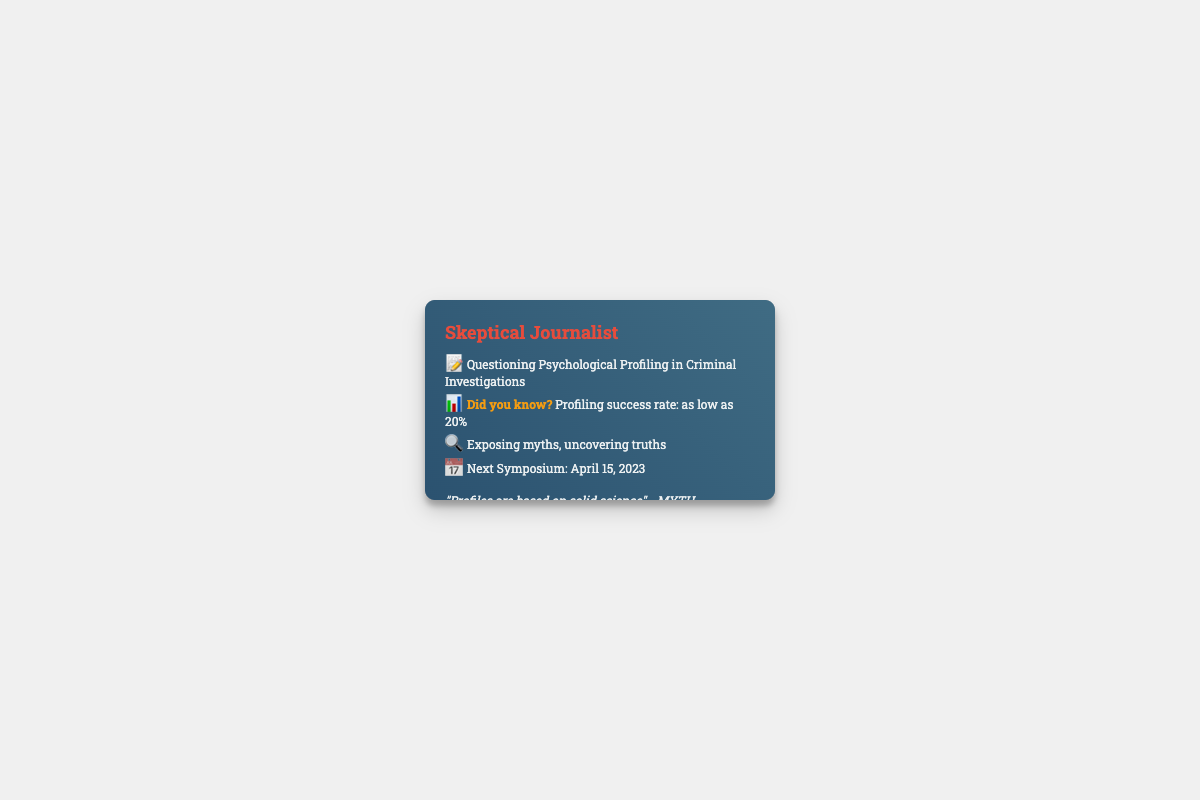What is the profession of the person on the card? The card states the person's profession clearly at the top, which is "Skeptical Journalist."
Answer: Skeptical Journalist What percentage indicates the profiling success rate? The document mentions a statistic regarding profiling success, specifically stating "as low as 20%."
Answer: 20% When is the next symposium scheduled? The card provides a specific date for the next symposium, which is "April 15, 2023."
Answer: April 15, 2023 What myth is debunked on the card? A specific claim about profiling is mentioned as a myth, which is highlighted as "Profiles are based on solid science - MYTH DEBUNKED."
Answer: Profiles are based on solid science What is the color of the text highlighted on the card? The card features a specific color for highlighting important information, which is "orange."
Answer: orange What type of inquiries does the card suggest the journalist is making? The card indicates the journalist's focus on exposing and uncovering truths about profiling, suggesting a critical inquiry.
Answer: Exposing myths, uncovering truths What visual element accentuates the card's content? An overlay is designed to enhance the card's aesthetic, as described in the document.
Answer: Overlay 